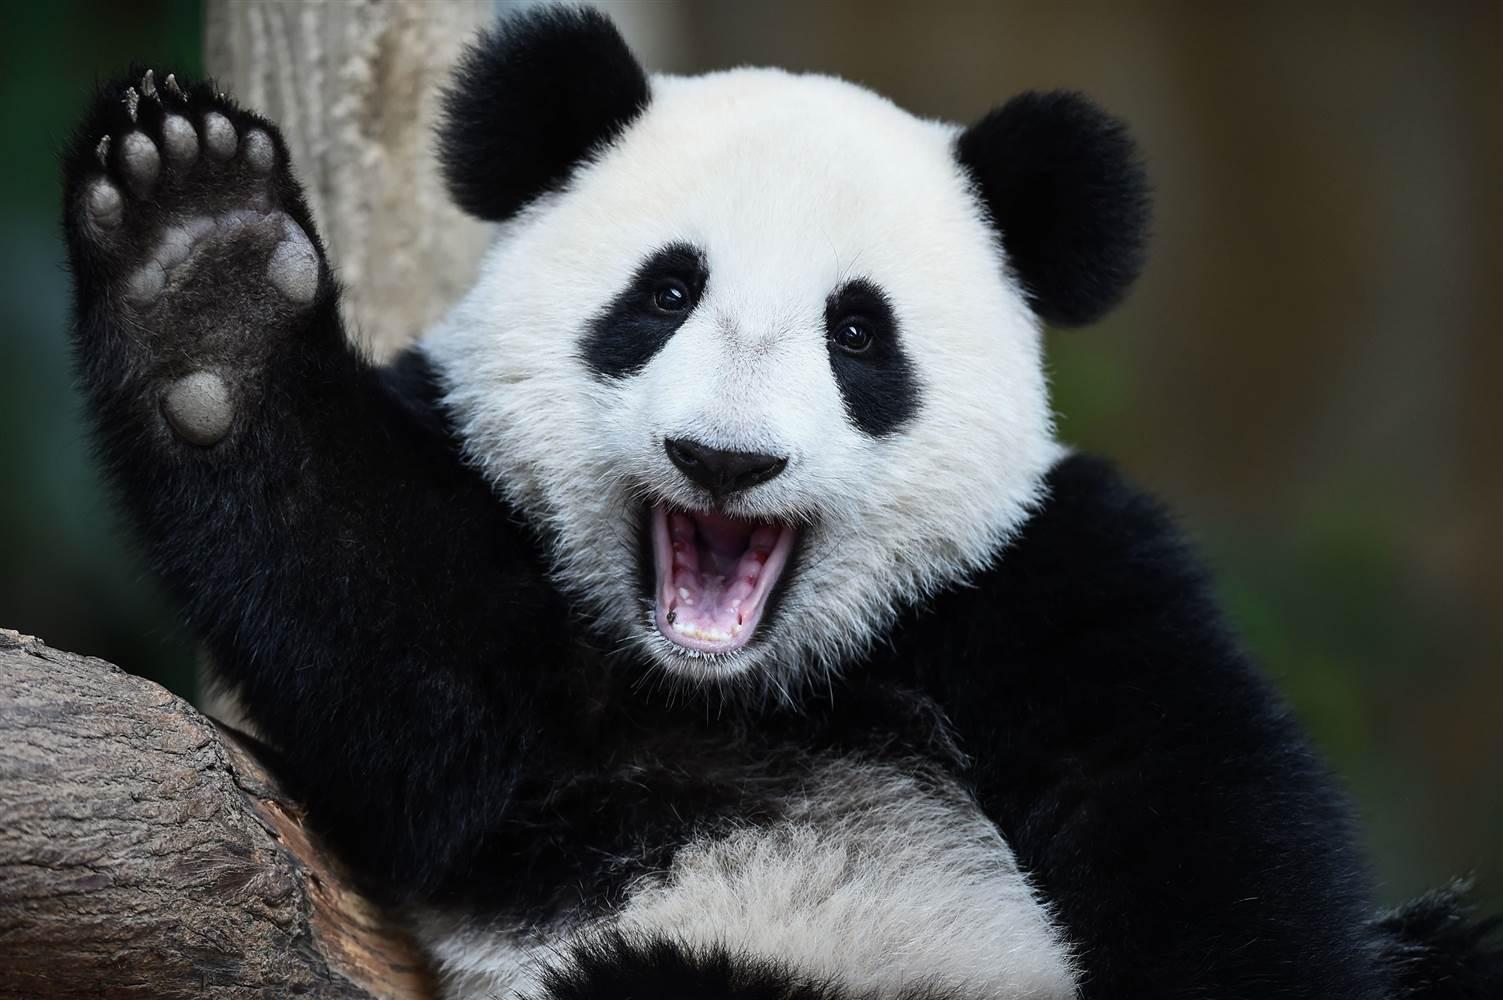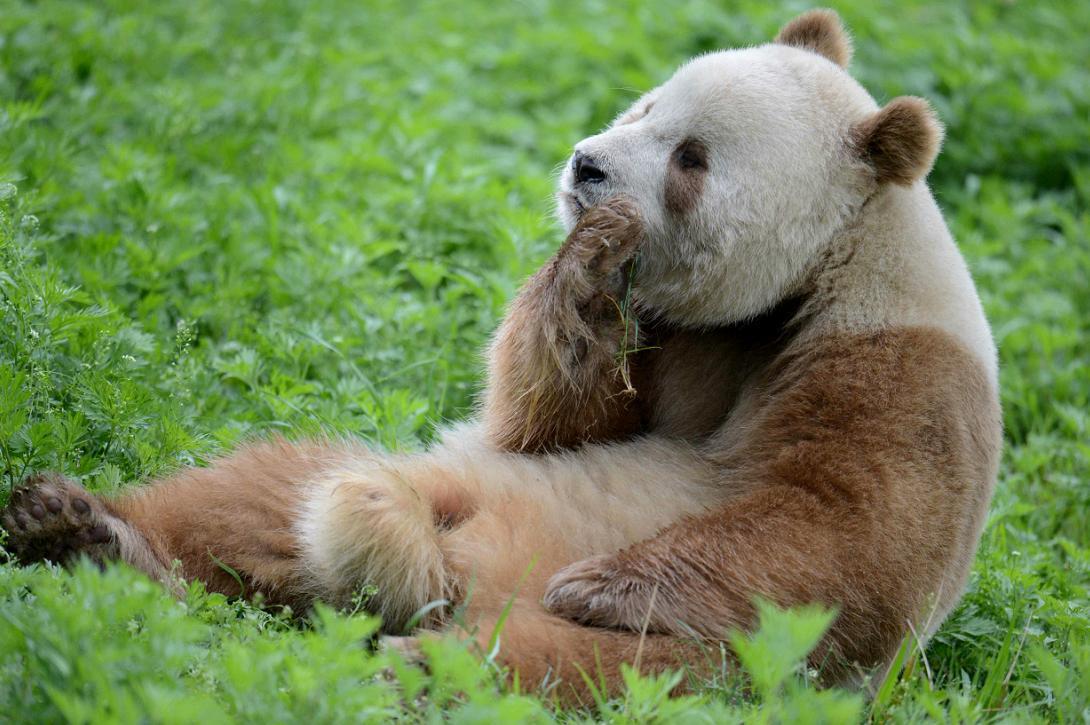The first image is the image on the left, the second image is the image on the right. Examine the images to the left and right. Is the description "An image shows a panda on its back with a smaller panda on top of it." accurate? Answer yes or no. No. The first image is the image on the left, the second image is the image on the right. Examine the images to the left and right. Is the description "A panda is playing with another panda in at least one of the images." accurate? Answer yes or no. No. 